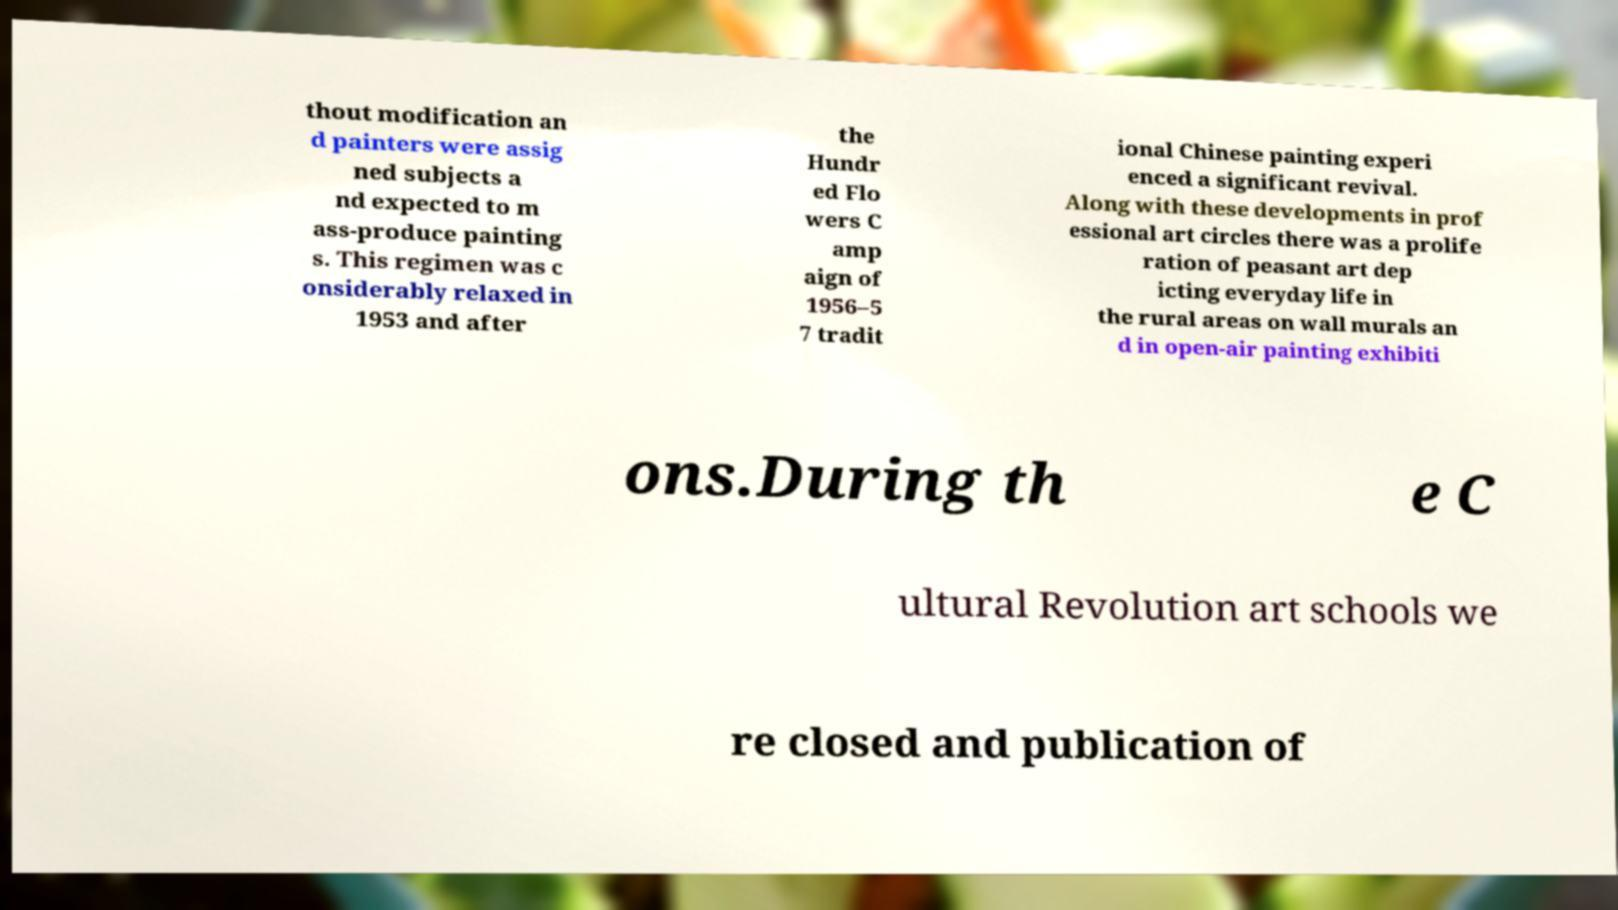Can you accurately transcribe the text from the provided image for me? thout modification an d painters were assig ned subjects a nd expected to m ass-produce painting s. This regimen was c onsiderably relaxed in 1953 and after the Hundr ed Flo wers C amp aign of 1956–5 7 tradit ional Chinese painting experi enced a significant revival. Along with these developments in prof essional art circles there was a prolife ration of peasant art dep icting everyday life in the rural areas on wall murals an d in open-air painting exhibiti ons.During th e C ultural Revolution art schools we re closed and publication of 